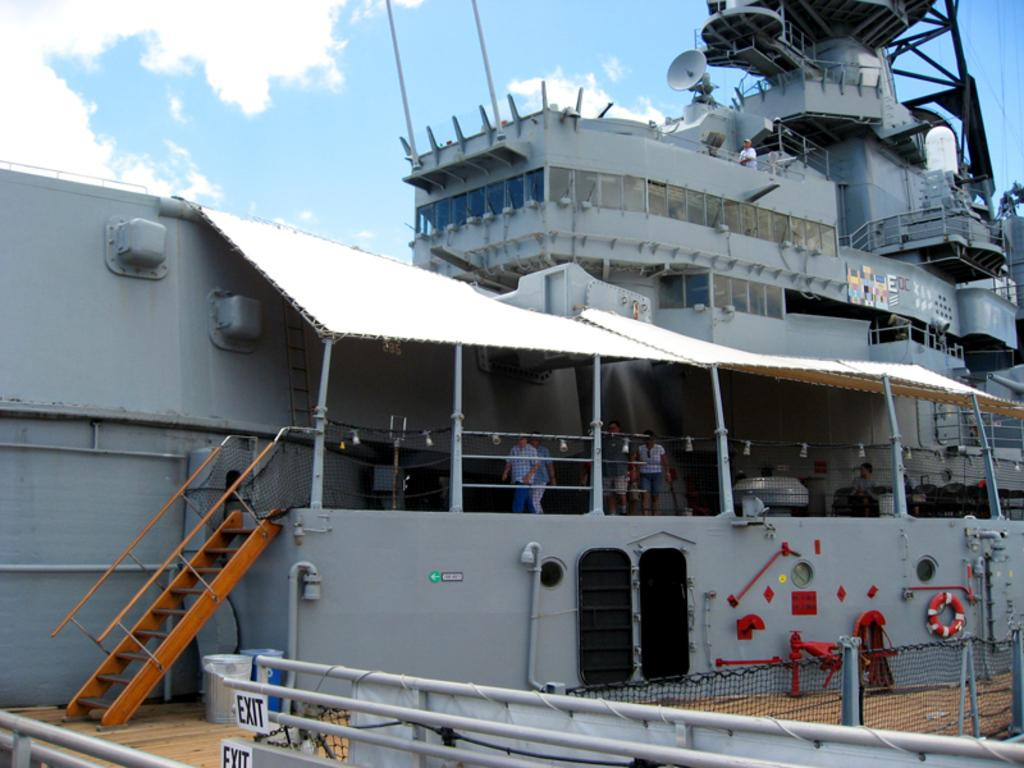<image>
Render a clear and concise summary of the photo. A large ship having an exit ramp in front of it. 